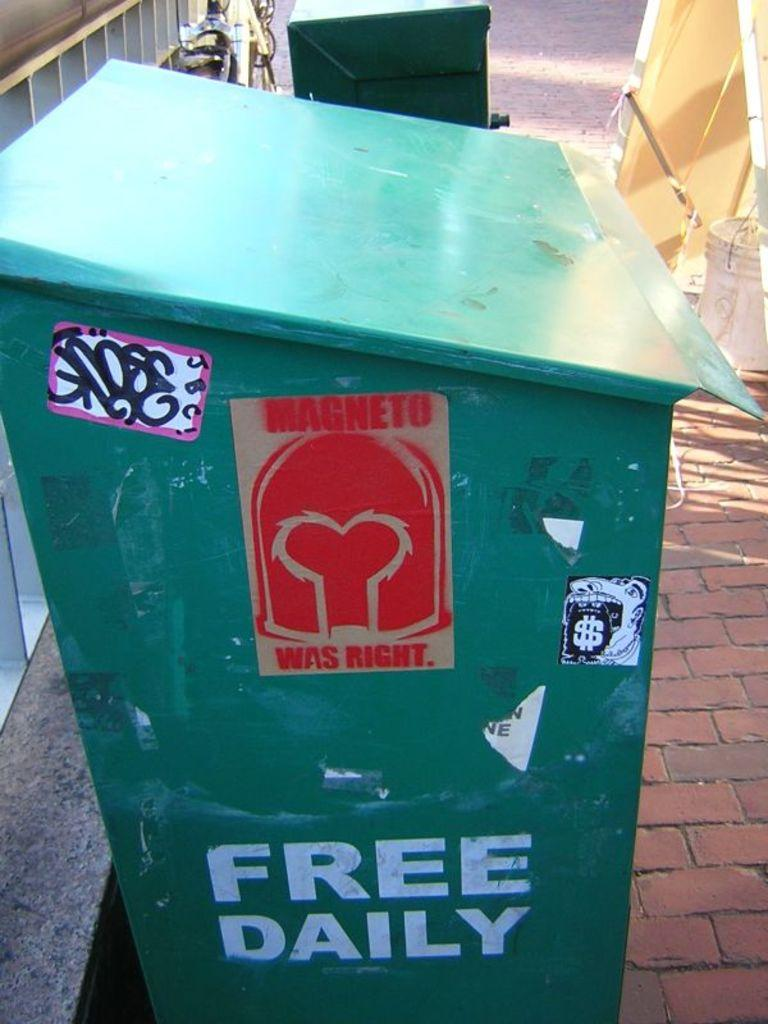<image>
Provide a brief description of the given image. A green container on a brick sidewalk that says free daily. 